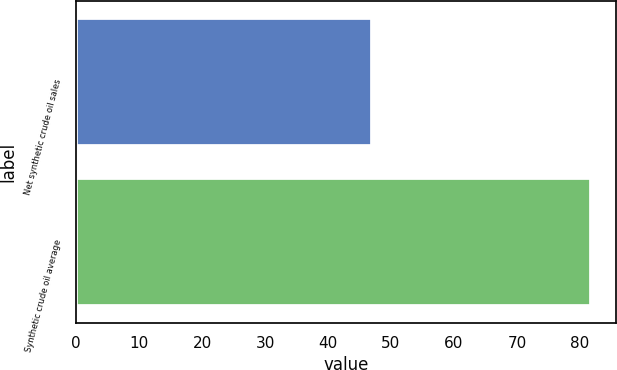Convert chart. <chart><loc_0><loc_0><loc_500><loc_500><bar_chart><fcel>Net synthetic crude oil sales<fcel>Synthetic crude oil average<nl><fcel>47<fcel>81.72<nl></chart> 